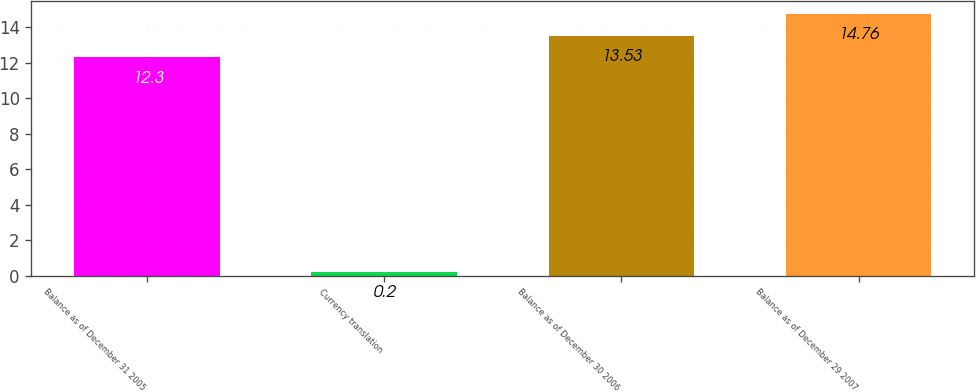Convert chart to OTSL. <chart><loc_0><loc_0><loc_500><loc_500><bar_chart><fcel>Balance as of December 31 2005<fcel>Currency translation<fcel>Balance as of December 30 2006<fcel>Balance as of December 29 2007<nl><fcel>12.3<fcel>0.2<fcel>13.53<fcel>14.76<nl></chart> 